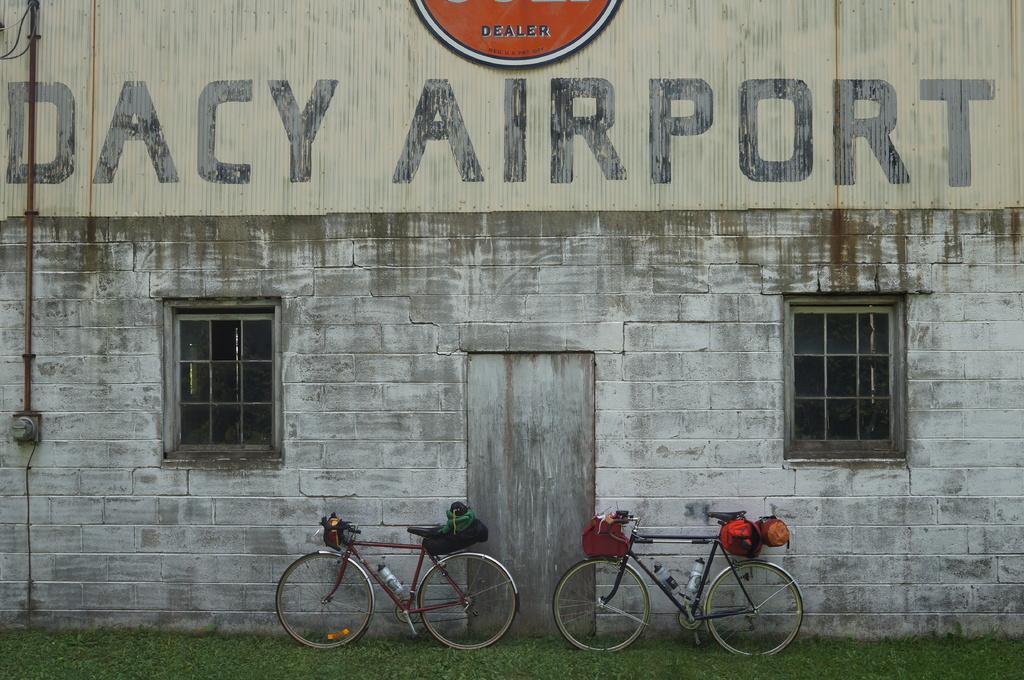Describe this image in one or two sentences. In this picture we can see couple of bicycles near the wall on the grass, and we can find baggage on the bicycles, and also we can see a metal rod on the wall. 